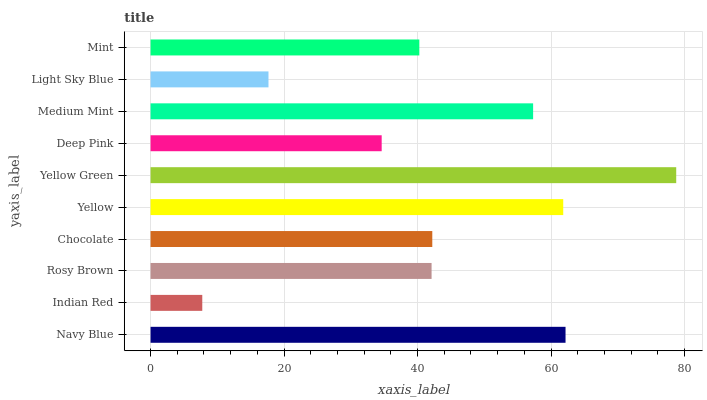Is Indian Red the minimum?
Answer yes or no. Yes. Is Yellow Green the maximum?
Answer yes or no. Yes. Is Rosy Brown the minimum?
Answer yes or no. No. Is Rosy Brown the maximum?
Answer yes or no. No. Is Rosy Brown greater than Indian Red?
Answer yes or no. Yes. Is Indian Red less than Rosy Brown?
Answer yes or no. Yes. Is Indian Red greater than Rosy Brown?
Answer yes or no. No. Is Rosy Brown less than Indian Red?
Answer yes or no. No. Is Chocolate the high median?
Answer yes or no. Yes. Is Rosy Brown the low median?
Answer yes or no. Yes. Is Light Sky Blue the high median?
Answer yes or no. No. Is Medium Mint the low median?
Answer yes or no. No. 